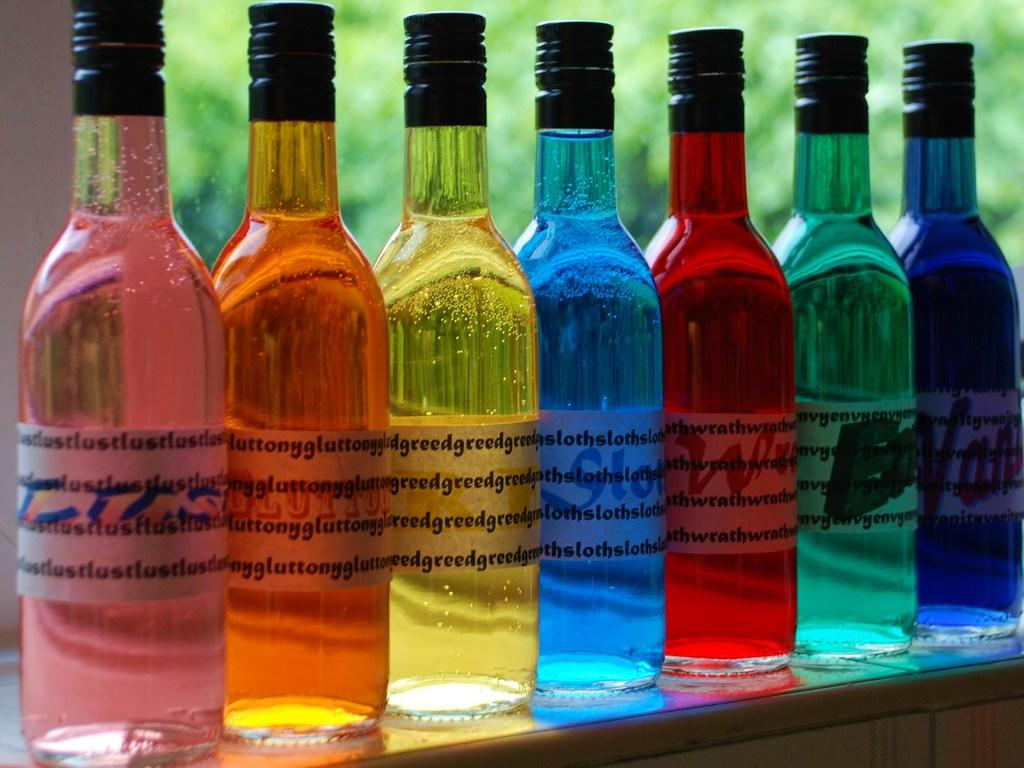<image>
Give a short and clear explanation of the subsequent image. colorful bottles in a window read Greed, Lust and Sloth 